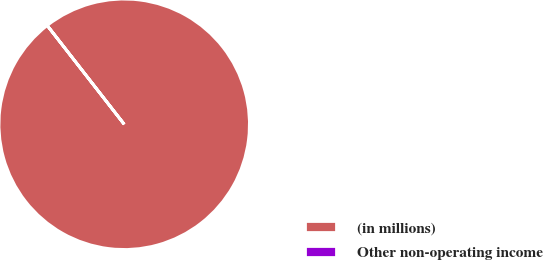Convert chart. <chart><loc_0><loc_0><loc_500><loc_500><pie_chart><fcel>(in millions)<fcel>Other non-operating income<nl><fcel>99.99%<fcel>0.01%<nl></chart> 